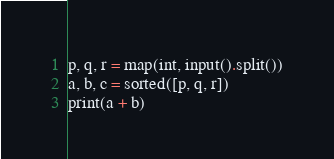Convert code to text. <code><loc_0><loc_0><loc_500><loc_500><_Python_>p, q, r = map(int, input().split())
a, b, c = sorted([p, q, r])
print(a + b)</code> 